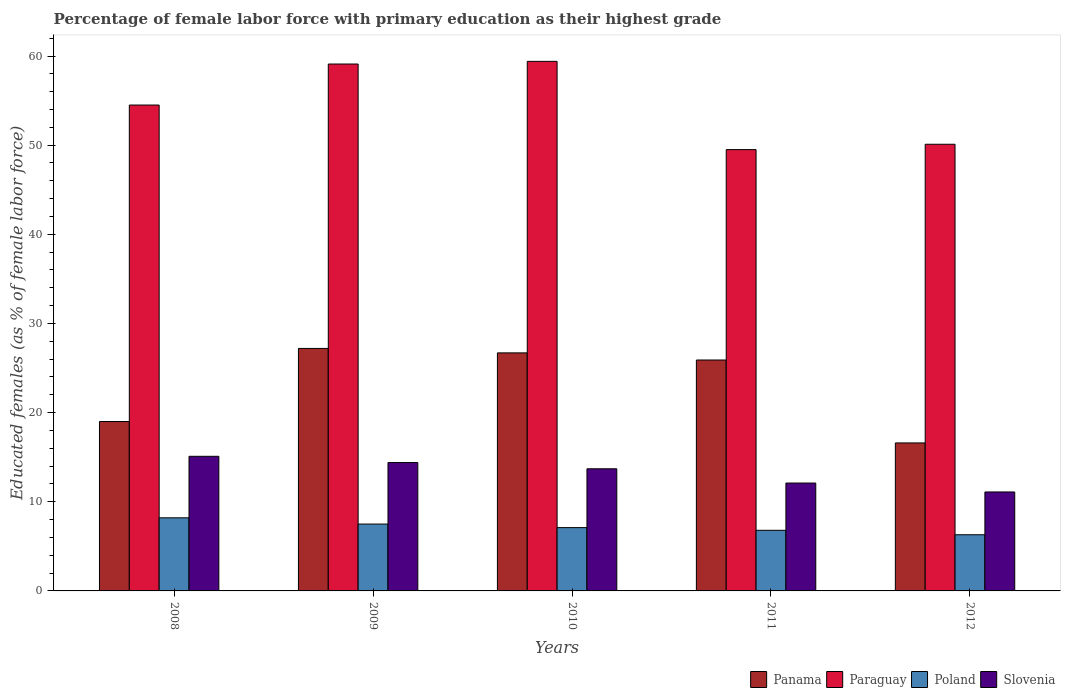How many different coloured bars are there?
Offer a very short reply. 4. How many groups of bars are there?
Your answer should be compact. 5. Are the number of bars per tick equal to the number of legend labels?
Offer a terse response. Yes. Are the number of bars on each tick of the X-axis equal?
Provide a succinct answer. Yes. How many bars are there on the 3rd tick from the left?
Offer a terse response. 4. What is the percentage of female labor force with primary education in Poland in 2011?
Your response must be concise. 6.8. Across all years, what is the maximum percentage of female labor force with primary education in Paraguay?
Your response must be concise. 59.4. Across all years, what is the minimum percentage of female labor force with primary education in Paraguay?
Ensure brevity in your answer.  49.5. In which year was the percentage of female labor force with primary education in Slovenia maximum?
Your answer should be very brief. 2008. In which year was the percentage of female labor force with primary education in Slovenia minimum?
Give a very brief answer. 2012. What is the total percentage of female labor force with primary education in Panama in the graph?
Your answer should be compact. 115.4. What is the difference between the percentage of female labor force with primary education in Slovenia in 2008 and that in 2010?
Offer a terse response. 1.4. What is the difference between the percentage of female labor force with primary education in Slovenia in 2011 and the percentage of female labor force with primary education in Paraguay in 2010?
Your answer should be very brief. -47.3. What is the average percentage of female labor force with primary education in Slovenia per year?
Ensure brevity in your answer.  13.28. In the year 2011, what is the difference between the percentage of female labor force with primary education in Panama and percentage of female labor force with primary education in Poland?
Give a very brief answer. 19.1. In how many years, is the percentage of female labor force with primary education in Slovenia greater than 6 %?
Keep it short and to the point. 5. What is the ratio of the percentage of female labor force with primary education in Poland in 2010 to that in 2011?
Keep it short and to the point. 1.04. Is the percentage of female labor force with primary education in Poland in 2008 less than that in 2010?
Your answer should be very brief. No. What is the difference between the highest and the second highest percentage of female labor force with primary education in Poland?
Keep it short and to the point. 0.7. What is the difference between the highest and the lowest percentage of female labor force with primary education in Panama?
Keep it short and to the point. 10.6. In how many years, is the percentage of female labor force with primary education in Slovenia greater than the average percentage of female labor force with primary education in Slovenia taken over all years?
Keep it short and to the point. 3. Is it the case that in every year, the sum of the percentage of female labor force with primary education in Paraguay and percentage of female labor force with primary education in Poland is greater than the sum of percentage of female labor force with primary education in Panama and percentage of female labor force with primary education in Slovenia?
Provide a succinct answer. Yes. What does the 1st bar from the right in 2011 represents?
Provide a succinct answer. Slovenia. Is it the case that in every year, the sum of the percentage of female labor force with primary education in Slovenia and percentage of female labor force with primary education in Paraguay is greater than the percentage of female labor force with primary education in Poland?
Keep it short and to the point. Yes. How many bars are there?
Give a very brief answer. 20. How many years are there in the graph?
Provide a short and direct response. 5. Are the values on the major ticks of Y-axis written in scientific E-notation?
Give a very brief answer. No. Does the graph contain any zero values?
Provide a succinct answer. No. Does the graph contain grids?
Provide a short and direct response. No. Where does the legend appear in the graph?
Offer a terse response. Bottom right. What is the title of the graph?
Your response must be concise. Percentage of female labor force with primary education as their highest grade. What is the label or title of the Y-axis?
Keep it short and to the point. Educated females (as % of female labor force). What is the Educated females (as % of female labor force) of Panama in 2008?
Keep it short and to the point. 19. What is the Educated females (as % of female labor force) in Paraguay in 2008?
Your response must be concise. 54.5. What is the Educated females (as % of female labor force) in Poland in 2008?
Your answer should be compact. 8.2. What is the Educated females (as % of female labor force) of Slovenia in 2008?
Your answer should be compact. 15.1. What is the Educated females (as % of female labor force) of Panama in 2009?
Provide a short and direct response. 27.2. What is the Educated females (as % of female labor force) of Paraguay in 2009?
Your answer should be very brief. 59.1. What is the Educated females (as % of female labor force) of Poland in 2009?
Keep it short and to the point. 7.5. What is the Educated females (as % of female labor force) in Slovenia in 2009?
Provide a succinct answer. 14.4. What is the Educated females (as % of female labor force) of Panama in 2010?
Give a very brief answer. 26.7. What is the Educated females (as % of female labor force) in Paraguay in 2010?
Your response must be concise. 59.4. What is the Educated females (as % of female labor force) of Poland in 2010?
Give a very brief answer. 7.1. What is the Educated females (as % of female labor force) of Slovenia in 2010?
Your response must be concise. 13.7. What is the Educated females (as % of female labor force) in Panama in 2011?
Give a very brief answer. 25.9. What is the Educated females (as % of female labor force) of Paraguay in 2011?
Keep it short and to the point. 49.5. What is the Educated females (as % of female labor force) of Poland in 2011?
Provide a short and direct response. 6.8. What is the Educated females (as % of female labor force) of Slovenia in 2011?
Make the answer very short. 12.1. What is the Educated females (as % of female labor force) of Panama in 2012?
Give a very brief answer. 16.6. What is the Educated females (as % of female labor force) in Paraguay in 2012?
Offer a terse response. 50.1. What is the Educated females (as % of female labor force) in Poland in 2012?
Make the answer very short. 6.3. What is the Educated females (as % of female labor force) of Slovenia in 2012?
Your answer should be compact. 11.1. Across all years, what is the maximum Educated females (as % of female labor force) in Panama?
Ensure brevity in your answer.  27.2. Across all years, what is the maximum Educated females (as % of female labor force) of Paraguay?
Keep it short and to the point. 59.4. Across all years, what is the maximum Educated females (as % of female labor force) in Poland?
Your response must be concise. 8.2. Across all years, what is the maximum Educated females (as % of female labor force) in Slovenia?
Keep it short and to the point. 15.1. Across all years, what is the minimum Educated females (as % of female labor force) in Panama?
Your answer should be compact. 16.6. Across all years, what is the minimum Educated females (as % of female labor force) of Paraguay?
Offer a terse response. 49.5. Across all years, what is the minimum Educated females (as % of female labor force) of Poland?
Provide a short and direct response. 6.3. Across all years, what is the minimum Educated females (as % of female labor force) in Slovenia?
Ensure brevity in your answer.  11.1. What is the total Educated females (as % of female labor force) in Panama in the graph?
Your answer should be very brief. 115.4. What is the total Educated females (as % of female labor force) of Paraguay in the graph?
Make the answer very short. 272.6. What is the total Educated females (as % of female labor force) in Poland in the graph?
Your response must be concise. 35.9. What is the total Educated females (as % of female labor force) in Slovenia in the graph?
Provide a short and direct response. 66.4. What is the difference between the Educated females (as % of female labor force) in Panama in 2008 and that in 2009?
Keep it short and to the point. -8.2. What is the difference between the Educated females (as % of female labor force) of Paraguay in 2008 and that in 2009?
Your answer should be very brief. -4.6. What is the difference between the Educated females (as % of female labor force) in Panama in 2008 and that in 2010?
Provide a short and direct response. -7.7. What is the difference between the Educated females (as % of female labor force) of Paraguay in 2008 and that in 2010?
Ensure brevity in your answer.  -4.9. What is the difference between the Educated females (as % of female labor force) of Panama in 2008 and that in 2011?
Ensure brevity in your answer.  -6.9. What is the difference between the Educated females (as % of female labor force) of Slovenia in 2008 and that in 2011?
Keep it short and to the point. 3. What is the difference between the Educated females (as % of female labor force) of Panama in 2008 and that in 2012?
Your response must be concise. 2.4. What is the difference between the Educated females (as % of female labor force) in Paraguay in 2008 and that in 2012?
Provide a succinct answer. 4.4. What is the difference between the Educated females (as % of female labor force) in Paraguay in 2009 and that in 2010?
Provide a succinct answer. -0.3. What is the difference between the Educated females (as % of female labor force) of Panama in 2009 and that in 2011?
Offer a very short reply. 1.3. What is the difference between the Educated females (as % of female labor force) of Paraguay in 2009 and that in 2011?
Ensure brevity in your answer.  9.6. What is the difference between the Educated females (as % of female labor force) of Poland in 2009 and that in 2011?
Ensure brevity in your answer.  0.7. What is the difference between the Educated females (as % of female labor force) of Slovenia in 2009 and that in 2011?
Keep it short and to the point. 2.3. What is the difference between the Educated females (as % of female labor force) in Paraguay in 2009 and that in 2012?
Your answer should be compact. 9. What is the difference between the Educated females (as % of female labor force) in Slovenia in 2009 and that in 2012?
Provide a short and direct response. 3.3. What is the difference between the Educated females (as % of female labor force) of Panama in 2010 and that in 2011?
Provide a succinct answer. 0.8. What is the difference between the Educated females (as % of female labor force) in Paraguay in 2010 and that in 2011?
Your response must be concise. 9.9. What is the difference between the Educated females (as % of female labor force) in Poland in 2010 and that in 2011?
Ensure brevity in your answer.  0.3. What is the difference between the Educated females (as % of female labor force) of Slovenia in 2010 and that in 2011?
Offer a terse response. 1.6. What is the difference between the Educated females (as % of female labor force) in Paraguay in 2010 and that in 2012?
Provide a short and direct response. 9.3. What is the difference between the Educated females (as % of female labor force) of Panama in 2011 and that in 2012?
Offer a terse response. 9.3. What is the difference between the Educated females (as % of female labor force) in Poland in 2011 and that in 2012?
Provide a succinct answer. 0.5. What is the difference between the Educated females (as % of female labor force) of Panama in 2008 and the Educated females (as % of female labor force) of Paraguay in 2009?
Give a very brief answer. -40.1. What is the difference between the Educated females (as % of female labor force) of Panama in 2008 and the Educated females (as % of female labor force) of Poland in 2009?
Ensure brevity in your answer.  11.5. What is the difference between the Educated females (as % of female labor force) in Panama in 2008 and the Educated females (as % of female labor force) in Slovenia in 2009?
Offer a very short reply. 4.6. What is the difference between the Educated females (as % of female labor force) in Paraguay in 2008 and the Educated females (as % of female labor force) in Slovenia in 2009?
Provide a short and direct response. 40.1. What is the difference between the Educated females (as % of female labor force) of Panama in 2008 and the Educated females (as % of female labor force) of Paraguay in 2010?
Give a very brief answer. -40.4. What is the difference between the Educated females (as % of female labor force) of Panama in 2008 and the Educated females (as % of female labor force) of Poland in 2010?
Your answer should be compact. 11.9. What is the difference between the Educated females (as % of female labor force) of Paraguay in 2008 and the Educated females (as % of female labor force) of Poland in 2010?
Keep it short and to the point. 47.4. What is the difference between the Educated females (as % of female labor force) of Paraguay in 2008 and the Educated females (as % of female labor force) of Slovenia in 2010?
Give a very brief answer. 40.8. What is the difference between the Educated females (as % of female labor force) in Poland in 2008 and the Educated females (as % of female labor force) in Slovenia in 2010?
Your answer should be compact. -5.5. What is the difference between the Educated females (as % of female labor force) of Panama in 2008 and the Educated females (as % of female labor force) of Paraguay in 2011?
Offer a very short reply. -30.5. What is the difference between the Educated females (as % of female labor force) of Panama in 2008 and the Educated females (as % of female labor force) of Poland in 2011?
Offer a very short reply. 12.2. What is the difference between the Educated females (as % of female labor force) of Panama in 2008 and the Educated females (as % of female labor force) of Slovenia in 2011?
Make the answer very short. 6.9. What is the difference between the Educated females (as % of female labor force) in Paraguay in 2008 and the Educated females (as % of female labor force) in Poland in 2011?
Your answer should be very brief. 47.7. What is the difference between the Educated females (as % of female labor force) in Paraguay in 2008 and the Educated females (as % of female labor force) in Slovenia in 2011?
Ensure brevity in your answer.  42.4. What is the difference between the Educated females (as % of female labor force) in Panama in 2008 and the Educated females (as % of female labor force) in Paraguay in 2012?
Give a very brief answer. -31.1. What is the difference between the Educated females (as % of female labor force) in Panama in 2008 and the Educated females (as % of female labor force) in Slovenia in 2012?
Make the answer very short. 7.9. What is the difference between the Educated females (as % of female labor force) in Paraguay in 2008 and the Educated females (as % of female labor force) in Poland in 2012?
Offer a terse response. 48.2. What is the difference between the Educated females (as % of female labor force) of Paraguay in 2008 and the Educated females (as % of female labor force) of Slovenia in 2012?
Your answer should be very brief. 43.4. What is the difference between the Educated females (as % of female labor force) of Panama in 2009 and the Educated females (as % of female labor force) of Paraguay in 2010?
Keep it short and to the point. -32.2. What is the difference between the Educated females (as % of female labor force) of Panama in 2009 and the Educated females (as % of female labor force) of Poland in 2010?
Your response must be concise. 20.1. What is the difference between the Educated females (as % of female labor force) in Paraguay in 2009 and the Educated females (as % of female labor force) in Poland in 2010?
Give a very brief answer. 52. What is the difference between the Educated females (as % of female labor force) of Paraguay in 2009 and the Educated females (as % of female labor force) of Slovenia in 2010?
Keep it short and to the point. 45.4. What is the difference between the Educated females (as % of female labor force) in Panama in 2009 and the Educated females (as % of female labor force) in Paraguay in 2011?
Give a very brief answer. -22.3. What is the difference between the Educated females (as % of female labor force) of Panama in 2009 and the Educated females (as % of female labor force) of Poland in 2011?
Provide a short and direct response. 20.4. What is the difference between the Educated females (as % of female labor force) in Panama in 2009 and the Educated females (as % of female labor force) in Slovenia in 2011?
Offer a very short reply. 15.1. What is the difference between the Educated females (as % of female labor force) in Paraguay in 2009 and the Educated females (as % of female labor force) in Poland in 2011?
Give a very brief answer. 52.3. What is the difference between the Educated females (as % of female labor force) of Panama in 2009 and the Educated females (as % of female labor force) of Paraguay in 2012?
Ensure brevity in your answer.  -22.9. What is the difference between the Educated females (as % of female labor force) of Panama in 2009 and the Educated females (as % of female labor force) of Poland in 2012?
Offer a very short reply. 20.9. What is the difference between the Educated females (as % of female labor force) in Paraguay in 2009 and the Educated females (as % of female labor force) in Poland in 2012?
Make the answer very short. 52.8. What is the difference between the Educated females (as % of female labor force) in Panama in 2010 and the Educated females (as % of female labor force) in Paraguay in 2011?
Your response must be concise. -22.8. What is the difference between the Educated females (as % of female labor force) in Panama in 2010 and the Educated females (as % of female labor force) in Poland in 2011?
Offer a terse response. 19.9. What is the difference between the Educated females (as % of female labor force) of Paraguay in 2010 and the Educated females (as % of female labor force) of Poland in 2011?
Provide a succinct answer. 52.6. What is the difference between the Educated females (as % of female labor force) of Paraguay in 2010 and the Educated females (as % of female labor force) of Slovenia in 2011?
Keep it short and to the point. 47.3. What is the difference between the Educated females (as % of female labor force) in Panama in 2010 and the Educated females (as % of female labor force) in Paraguay in 2012?
Give a very brief answer. -23.4. What is the difference between the Educated females (as % of female labor force) in Panama in 2010 and the Educated females (as % of female labor force) in Poland in 2012?
Offer a very short reply. 20.4. What is the difference between the Educated females (as % of female labor force) of Panama in 2010 and the Educated females (as % of female labor force) of Slovenia in 2012?
Make the answer very short. 15.6. What is the difference between the Educated females (as % of female labor force) of Paraguay in 2010 and the Educated females (as % of female labor force) of Poland in 2012?
Offer a very short reply. 53.1. What is the difference between the Educated females (as % of female labor force) of Paraguay in 2010 and the Educated females (as % of female labor force) of Slovenia in 2012?
Ensure brevity in your answer.  48.3. What is the difference between the Educated females (as % of female labor force) of Poland in 2010 and the Educated females (as % of female labor force) of Slovenia in 2012?
Make the answer very short. -4. What is the difference between the Educated females (as % of female labor force) in Panama in 2011 and the Educated females (as % of female labor force) in Paraguay in 2012?
Offer a terse response. -24.2. What is the difference between the Educated females (as % of female labor force) of Panama in 2011 and the Educated females (as % of female labor force) of Poland in 2012?
Give a very brief answer. 19.6. What is the difference between the Educated females (as % of female labor force) in Paraguay in 2011 and the Educated females (as % of female labor force) in Poland in 2012?
Your answer should be compact. 43.2. What is the difference between the Educated females (as % of female labor force) in Paraguay in 2011 and the Educated females (as % of female labor force) in Slovenia in 2012?
Offer a very short reply. 38.4. What is the difference between the Educated females (as % of female labor force) of Poland in 2011 and the Educated females (as % of female labor force) of Slovenia in 2012?
Offer a terse response. -4.3. What is the average Educated females (as % of female labor force) in Panama per year?
Keep it short and to the point. 23.08. What is the average Educated females (as % of female labor force) of Paraguay per year?
Offer a terse response. 54.52. What is the average Educated females (as % of female labor force) in Poland per year?
Your answer should be compact. 7.18. What is the average Educated females (as % of female labor force) of Slovenia per year?
Your answer should be very brief. 13.28. In the year 2008, what is the difference between the Educated females (as % of female labor force) in Panama and Educated females (as % of female labor force) in Paraguay?
Give a very brief answer. -35.5. In the year 2008, what is the difference between the Educated females (as % of female labor force) of Panama and Educated females (as % of female labor force) of Poland?
Ensure brevity in your answer.  10.8. In the year 2008, what is the difference between the Educated females (as % of female labor force) in Panama and Educated females (as % of female labor force) in Slovenia?
Provide a short and direct response. 3.9. In the year 2008, what is the difference between the Educated females (as % of female labor force) of Paraguay and Educated females (as % of female labor force) of Poland?
Give a very brief answer. 46.3. In the year 2008, what is the difference between the Educated females (as % of female labor force) of Paraguay and Educated females (as % of female labor force) of Slovenia?
Offer a very short reply. 39.4. In the year 2009, what is the difference between the Educated females (as % of female labor force) in Panama and Educated females (as % of female labor force) in Paraguay?
Your answer should be very brief. -31.9. In the year 2009, what is the difference between the Educated females (as % of female labor force) of Panama and Educated females (as % of female labor force) of Poland?
Provide a short and direct response. 19.7. In the year 2009, what is the difference between the Educated females (as % of female labor force) of Panama and Educated females (as % of female labor force) of Slovenia?
Offer a very short reply. 12.8. In the year 2009, what is the difference between the Educated females (as % of female labor force) in Paraguay and Educated females (as % of female labor force) in Poland?
Offer a terse response. 51.6. In the year 2009, what is the difference between the Educated females (as % of female labor force) in Paraguay and Educated females (as % of female labor force) in Slovenia?
Offer a very short reply. 44.7. In the year 2009, what is the difference between the Educated females (as % of female labor force) in Poland and Educated females (as % of female labor force) in Slovenia?
Provide a short and direct response. -6.9. In the year 2010, what is the difference between the Educated females (as % of female labor force) of Panama and Educated females (as % of female labor force) of Paraguay?
Offer a very short reply. -32.7. In the year 2010, what is the difference between the Educated females (as % of female labor force) of Panama and Educated females (as % of female labor force) of Poland?
Your response must be concise. 19.6. In the year 2010, what is the difference between the Educated females (as % of female labor force) in Paraguay and Educated females (as % of female labor force) in Poland?
Your response must be concise. 52.3. In the year 2010, what is the difference between the Educated females (as % of female labor force) in Paraguay and Educated females (as % of female labor force) in Slovenia?
Your response must be concise. 45.7. In the year 2011, what is the difference between the Educated females (as % of female labor force) in Panama and Educated females (as % of female labor force) in Paraguay?
Offer a terse response. -23.6. In the year 2011, what is the difference between the Educated females (as % of female labor force) in Panama and Educated females (as % of female labor force) in Poland?
Your response must be concise. 19.1. In the year 2011, what is the difference between the Educated females (as % of female labor force) in Paraguay and Educated females (as % of female labor force) in Poland?
Give a very brief answer. 42.7. In the year 2011, what is the difference between the Educated females (as % of female labor force) of Paraguay and Educated females (as % of female labor force) of Slovenia?
Make the answer very short. 37.4. In the year 2011, what is the difference between the Educated females (as % of female labor force) in Poland and Educated females (as % of female labor force) in Slovenia?
Your answer should be compact. -5.3. In the year 2012, what is the difference between the Educated females (as % of female labor force) of Panama and Educated females (as % of female labor force) of Paraguay?
Keep it short and to the point. -33.5. In the year 2012, what is the difference between the Educated females (as % of female labor force) of Panama and Educated females (as % of female labor force) of Poland?
Ensure brevity in your answer.  10.3. In the year 2012, what is the difference between the Educated females (as % of female labor force) in Paraguay and Educated females (as % of female labor force) in Poland?
Your answer should be very brief. 43.8. In the year 2012, what is the difference between the Educated females (as % of female labor force) in Paraguay and Educated females (as % of female labor force) in Slovenia?
Your answer should be compact. 39. In the year 2012, what is the difference between the Educated females (as % of female labor force) of Poland and Educated females (as % of female labor force) of Slovenia?
Provide a succinct answer. -4.8. What is the ratio of the Educated females (as % of female labor force) in Panama in 2008 to that in 2009?
Provide a short and direct response. 0.7. What is the ratio of the Educated females (as % of female labor force) of Paraguay in 2008 to that in 2009?
Provide a succinct answer. 0.92. What is the ratio of the Educated females (as % of female labor force) of Poland in 2008 to that in 2009?
Your answer should be compact. 1.09. What is the ratio of the Educated females (as % of female labor force) in Slovenia in 2008 to that in 2009?
Provide a short and direct response. 1.05. What is the ratio of the Educated females (as % of female labor force) in Panama in 2008 to that in 2010?
Provide a succinct answer. 0.71. What is the ratio of the Educated females (as % of female labor force) of Paraguay in 2008 to that in 2010?
Your answer should be compact. 0.92. What is the ratio of the Educated females (as % of female labor force) in Poland in 2008 to that in 2010?
Ensure brevity in your answer.  1.15. What is the ratio of the Educated females (as % of female labor force) in Slovenia in 2008 to that in 2010?
Give a very brief answer. 1.1. What is the ratio of the Educated females (as % of female labor force) in Panama in 2008 to that in 2011?
Provide a succinct answer. 0.73. What is the ratio of the Educated females (as % of female labor force) in Paraguay in 2008 to that in 2011?
Offer a very short reply. 1.1. What is the ratio of the Educated females (as % of female labor force) of Poland in 2008 to that in 2011?
Provide a short and direct response. 1.21. What is the ratio of the Educated females (as % of female labor force) in Slovenia in 2008 to that in 2011?
Make the answer very short. 1.25. What is the ratio of the Educated females (as % of female labor force) in Panama in 2008 to that in 2012?
Offer a very short reply. 1.14. What is the ratio of the Educated females (as % of female labor force) in Paraguay in 2008 to that in 2012?
Ensure brevity in your answer.  1.09. What is the ratio of the Educated females (as % of female labor force) in Poland in 2008 to that in 2012?
Offer a terse response. 1.3. What is the ratio of the Educated females (as % of female labor force) in Slovenia in 2008 to that in 2012?
Keep it short and to the point. 1.36. What is the ratio of the Educated females (as % of female labor force) in Panama in 2009 to that in 2010?
Your response must be concise. 1.02. What is the ratio of the Educated females (as % of female labor force) in Poland in 2009 to that in 2010?
Ensure brevity in your answer.  1.06. What is the ratio of the Educated females (as % of female labor force) in Slovenia in 2009 to that in 2010?
Ensure brevity in your answer.  1.05. What is the ratio of the Educated females (as % of female labor force) of Panama in 2009 to that in 2011?
Your answer should be compact. 1.05. What is the ratio of the Educated females (as % of female labor force) of Paraguay in 2009 to that in 2011?
Your answer should be compact. 1.19. What is the ratio of the Educated females (as % of female labor force) in Poland in 2009 to that in 2011?
Give a very brief answer. 1.1. What is the ratio of the Educated females (as % of female labor force) of Slovenia in 2009 to that in 2011?
Make the answer very short. 1.19. What is the ratio of the Educated females (as % of female labor force) in Panama in 2009 to that in 2012?
Provide a short and direct response. 1.64. What is the ratio of the Educated females (as % of female labor force) of Paraguay in 2009 to that in 2012?
Offer a very short reply. 1.18. What is the ratio of the Educated females (as % of female labor force) in Poland in 2009 to that in 2012?
Offer a terse response. 1.19. What is the ratio of the Educated females (as % of female labor force) in Slovenia in 2009 to that in 2012?
Keep it short and to the point. 1.3. What is the ratio of the Educated females (as % of female labor force) in Panama in 2010 to that in 2011?
Make the answer very short. 1.03. What is the ratio of the Educated females (as % of female labor force) in Poland in 2010 to that in 2011?
Keep it short and to the point. 1.04. What is the ratio of the Educated females (as % of female labor force) of Slovenia in 2010 to that in 2011?
Offer a very short reply. 1.13. What is the ratio of the Educated females (as % of female labor force) of Panama in 2010 to that in 2012?
Provide a succinct answer. 1.61. What is the ratio of the Educated females (as % of female labor force) in Paraguay in 2010 to that in 2012?
Your response must be concise. 1.19. What is the ratio of the Educated females (as % of female labor force) in Poland in 2010 to that in 2012?
Provide a short and direct response. 1.13. What is the ratio of the Educated females (as % of female labor force) of Slovenia in 2010 to that in 2012?
Your response must be concise. 1.23. What is the ratio of the Educated females (as % of female labor force) of Panama in 2011 to that in 2012?
Provide a succinct answer. 1.56. What is the ratio of the Educated females (as % of female labor force) of Paraguay in 2011 to that in 2012?
Give a very brief answer. 0.99. What is the ratio of the Educated females (as % of female labor force) in Poland in 2011 to that in 2012?
Offer a very short reply. 1.08. What is the ratio of the Educated females (as % of female labor force) of Slovenia in 2011 to that in 2012?
Provide a succinct answer. 1.09. What is the difference between the highest and the lowest Educated females (as % of female labor force) in Panama?
Provide a short and direct response. 10.6. What is the difference between the highest and the lowest Educated females (as % of female labor force) of Poland?
Ensure brevity in your answer.  1.9. What is the difference between the highest and the lowest Educated females (as % of female labor force) in Slovenia?
Provide a short and direct response. 4. 